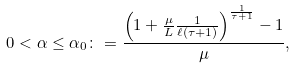<formula> <loc_0><loc_0><loc_500><loc_500>0 < \alpha \leq \alpha _ { 0 } \colon = \frac { \left ( 1 + \frac { \mu } { L } \frac { 1 } { \ell ( \tau + 1 ) } \right ) ^ { \frac { 1 } { \tau + 1 } } - 1 } { \mu } ,</formula> 